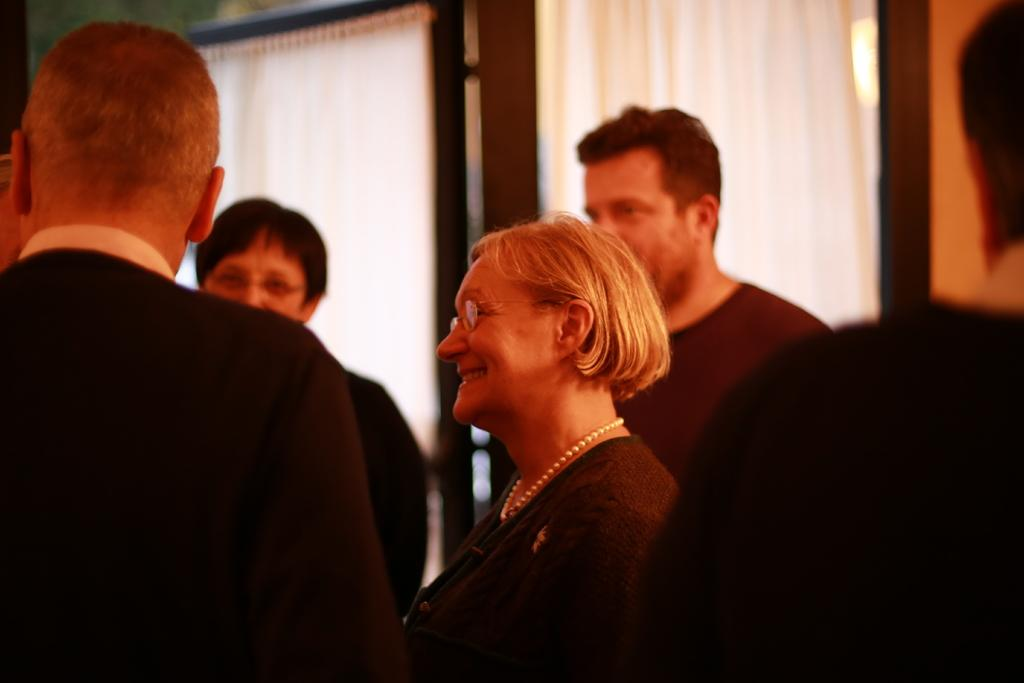What types of people are in the image? There are men and women in the image. What are the men and women doing in the image? The men and women are standing. What color clothes are the men and women wearing? The men and women are wearing black clothes. Can you tell me how many times the comb is used in the image? There is no comb present in the image, so it cannot be used. 